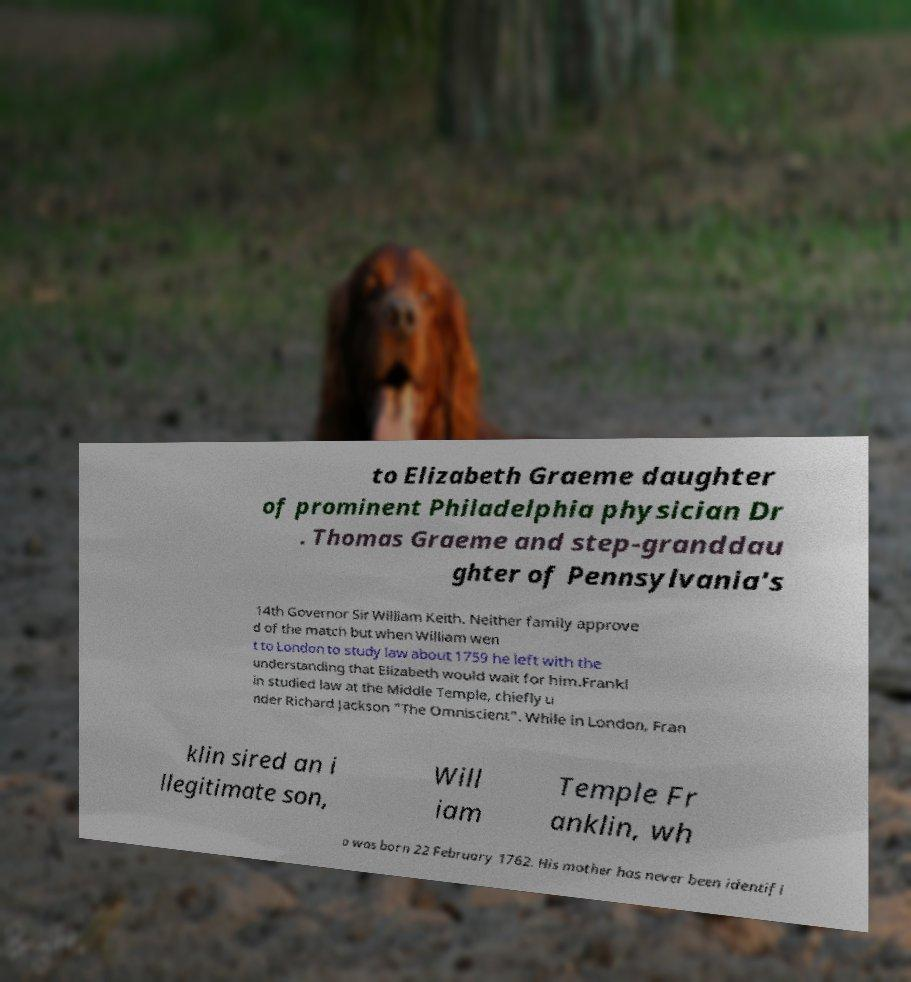Can you accurately transcribe the text from the provided image for me? to Elizabeth Graeme daughter of prominent Philadelphia physician Dr . Thomas Graeme and step-granddau ghter of Pennsylvania's 14th Governor Sir William Keith. Neither family approve d of the match but when William wen t to London to study law about 1759 he left with the understanding that Elizabeth would wait for him.Frankl in studied law at the Middle Temple, chiefly u nder Richard Jackson "The Omniscient". While in London, Fran klin sired an i llegitimate son, Will iam Temple Fr anklin, wh o was born 22 February 1762. His mother has never been identifi 